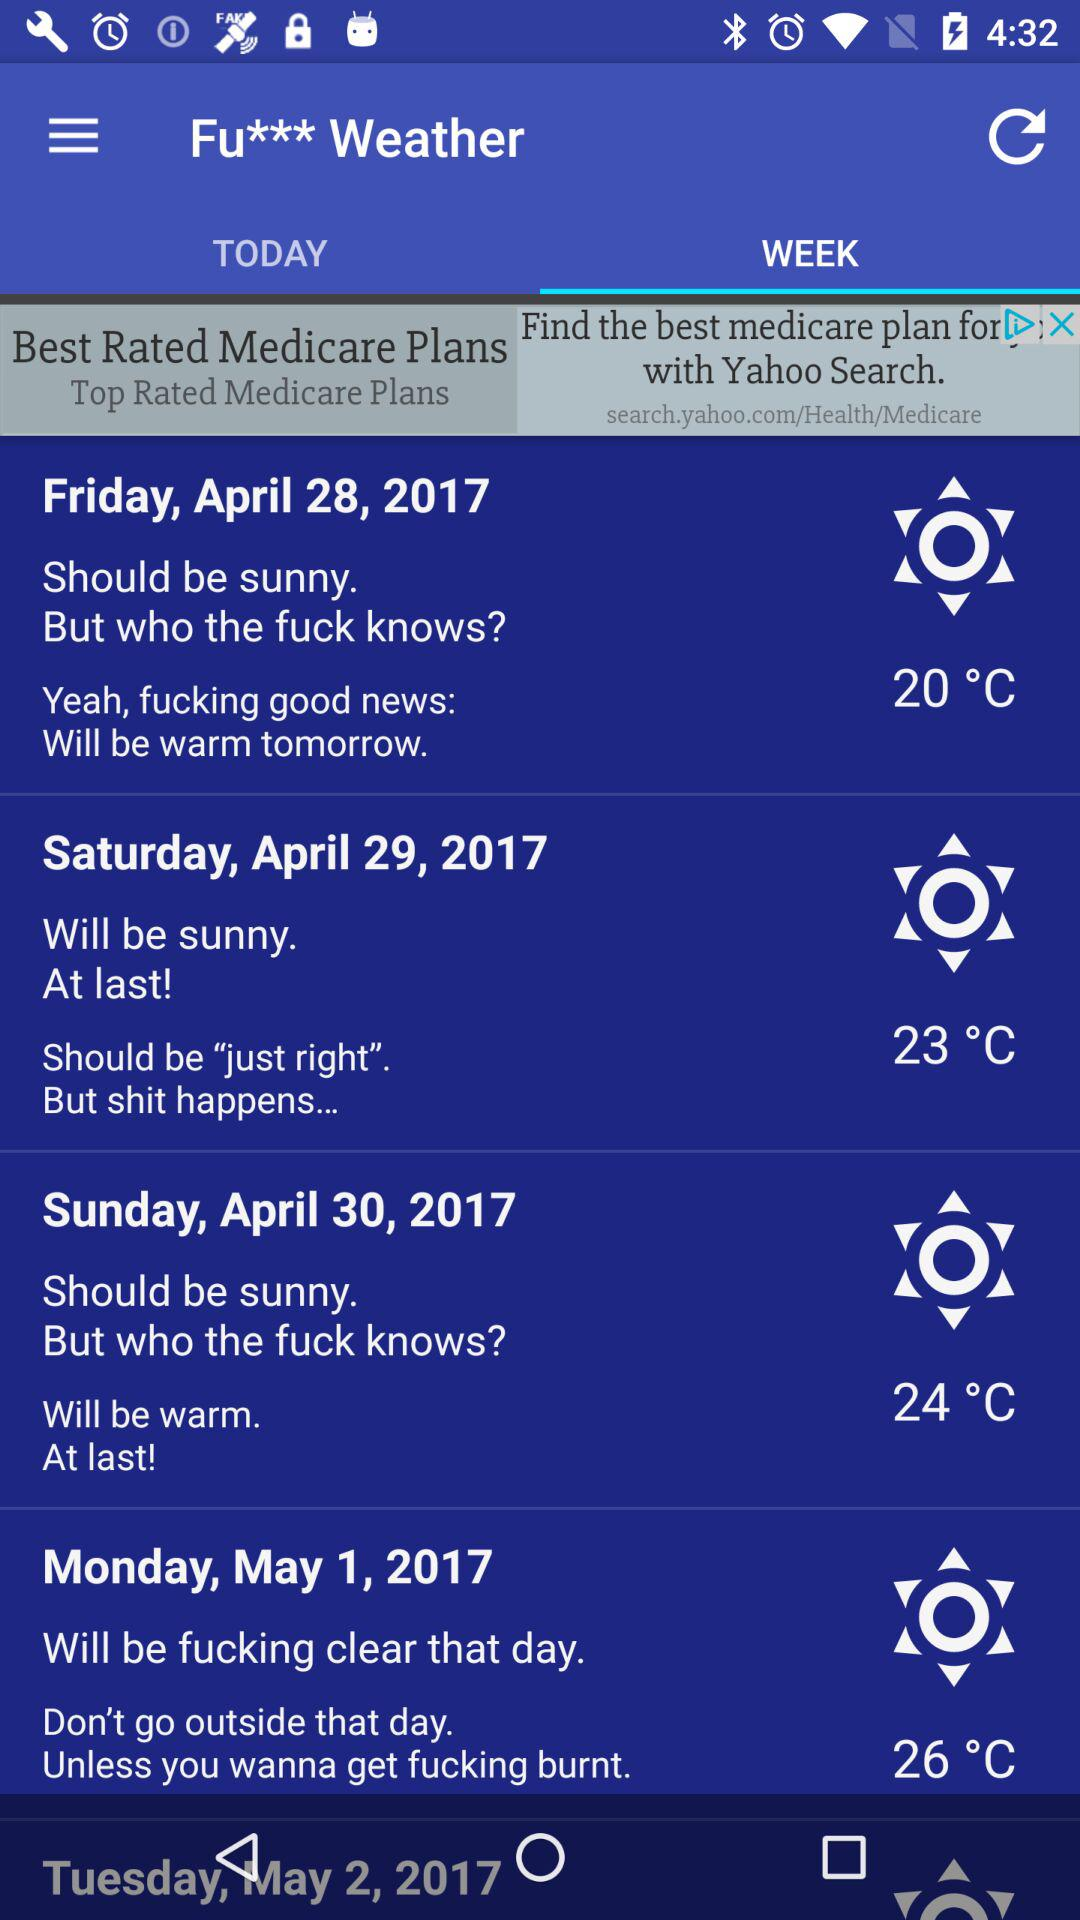What is the weather condition on April 29, 2017? The weather condition is sunny on April 29, 2017. 